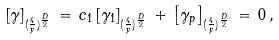Convert formula to latex. <formula><loc_0><loc_0><loc_500><loc_500>\left [ \gamma \right ] _ { ( \frac { 4 } { y } ) ^ { \frac { D } { 2 } } } \, = \, c _ { 1 } \left [ \gamma _ { 1 } \right ] _ { ( \frac { 4 } { y } ) ^ { \frac { D } { 2 } } } \, + \, \left [ \gamma _ { p } \right ] _ { ( \frac { 4 } { y } ) ^ { \frac { D } { 2 } } } \, = \, 0 \, ,</formula> 